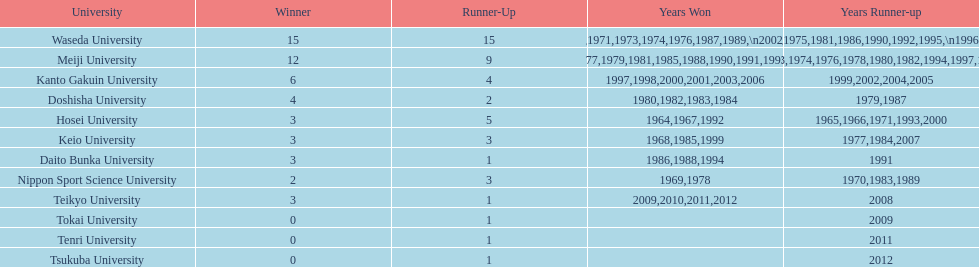Who triumphed in the final championship noted on this table? Teikyo University. 